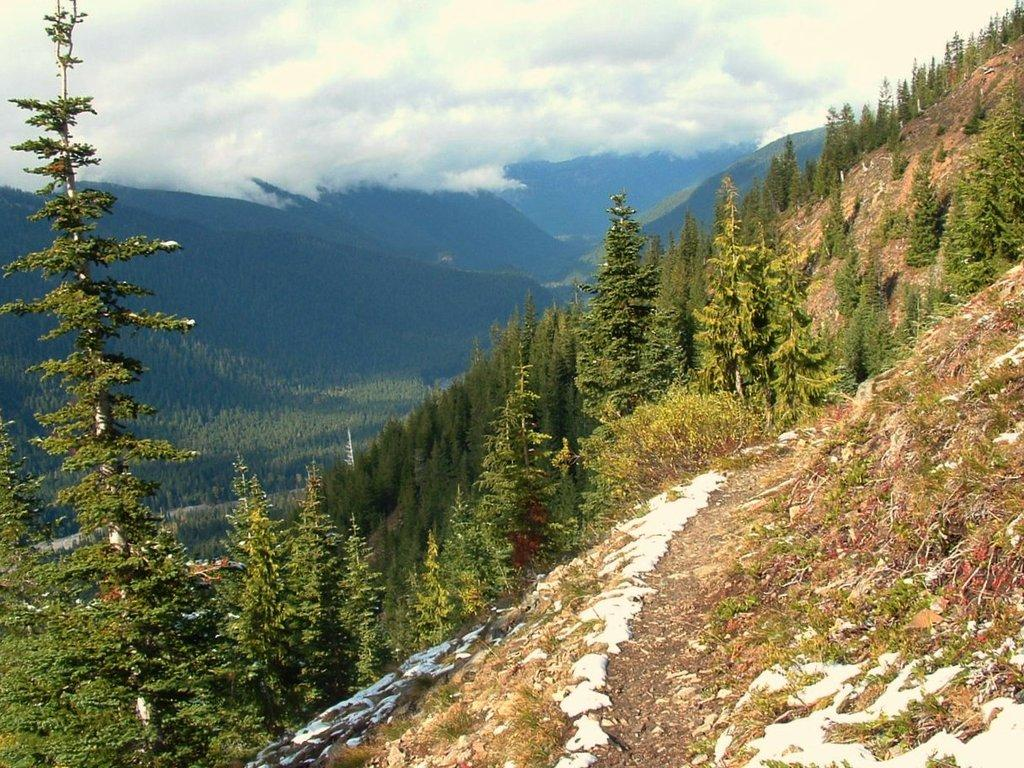What type of vegetation is in the front of the image? There are plants in the front of the image. What type of vegetation is in the background of the image? There are trees in the background of the image. What is visible above the plants and trees in the image? The sky is visible in the image. What can be seen in the sky in the image? Clouds are present in the sky. What type of leather is being used to make the beetle fly in the image? There is no beetle or leather present in the image. 